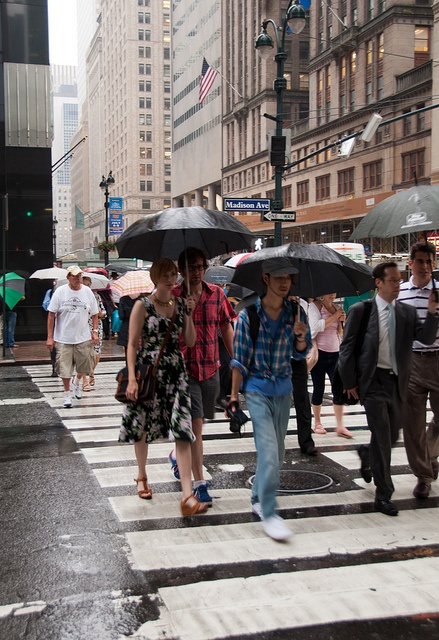Describe the objects in this image and their specific colors. I can see people in black, gray, and maroon tones, people in black, gray, navy, and blue tones, people in black, gray, maroon, and darkgray tones, people in black, maroon, gray, and brown tones, and umbrella in black, gray, darkgray, and lightgray tones in this image. 